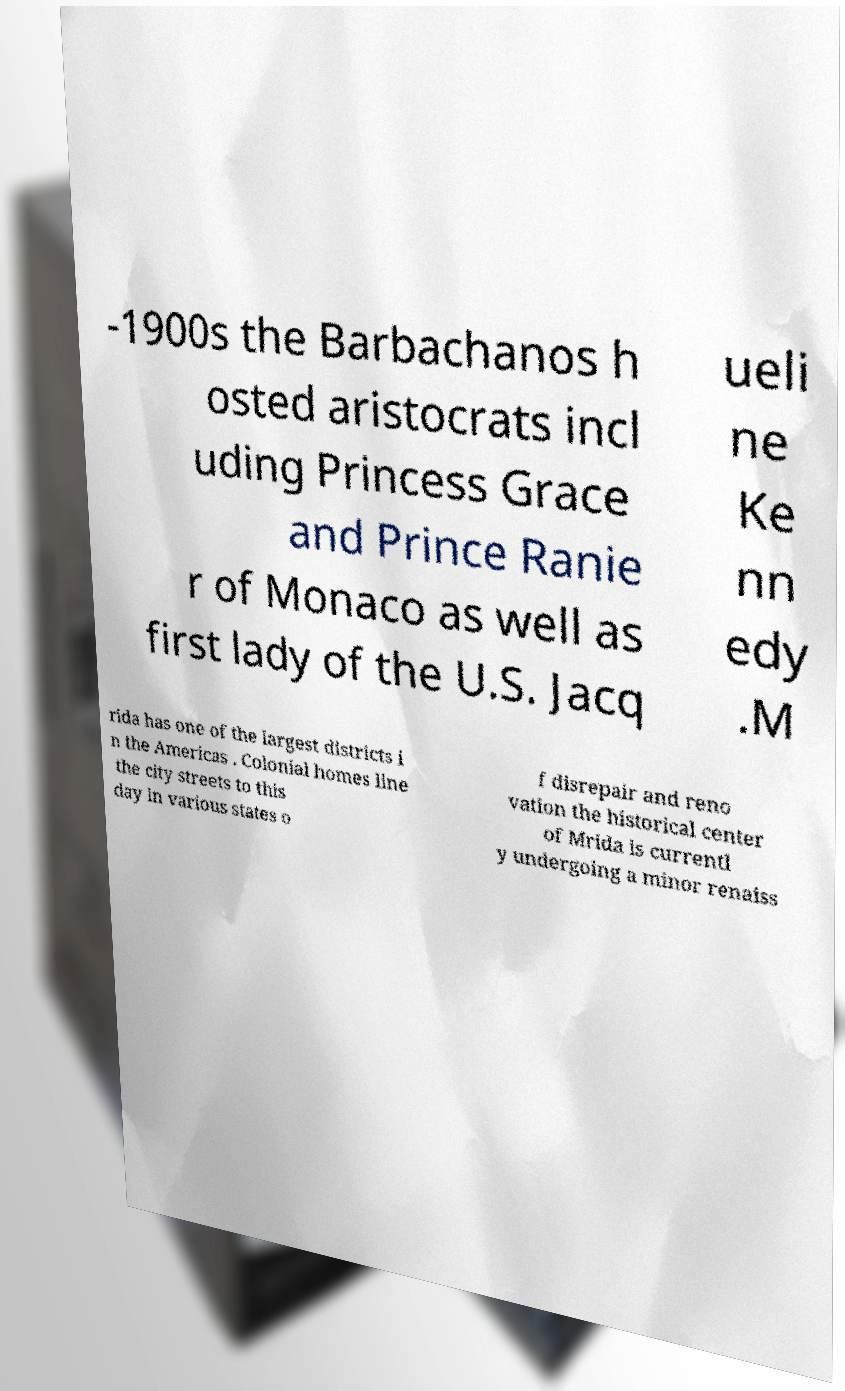Please identify and transcribe the text found in this image. -1900s the Barbachanos h osted aristocrats incl uding Princess Grace and Prince Ranie r of Monaco as well as first lady of the U.S. Jacq ueli ne Ke nn edy .M rida has one of the largest districts i n the Americas . Colonial homes line the city streets to this day in various states o f disrepair and reno vation the historical center of Mrida is currentl y undergoing a minor renaiss 